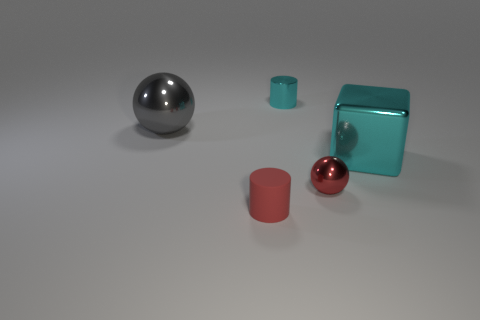Can you estimate the size relationships among these objects? Certainly! The objects vary in size. The large teal cube and the large sphere are the biggest, whereas the small red matte cylinder and the small cyan cube are significantly smaller in comparison. Considering the lighting, where do you think the light source is located in this scene? Based on the shadows and highlights, the light source seems to be coming from the upper left side, outside of the scene. 